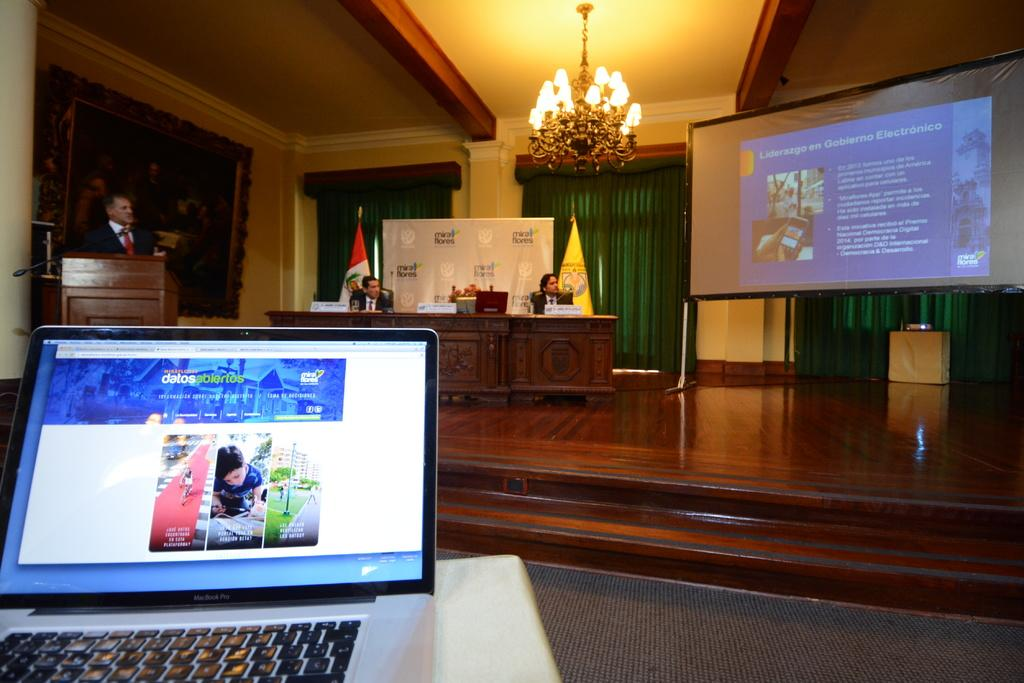What electronic device is visible in the image? There is a laptop in the image. What can be seen in the background of the image? There are people sitting in the background of the image. Where is the person standing in the image? There is a person standing on the left side of the image. What is the purpose of the screen in the image? The purpose of the screen is not explicitly mentioned, but it could be part of the laptop or a separate device. How many chairs are visible in the image? There is no mention of chairs in the image, so it is not possible to determine their number. 